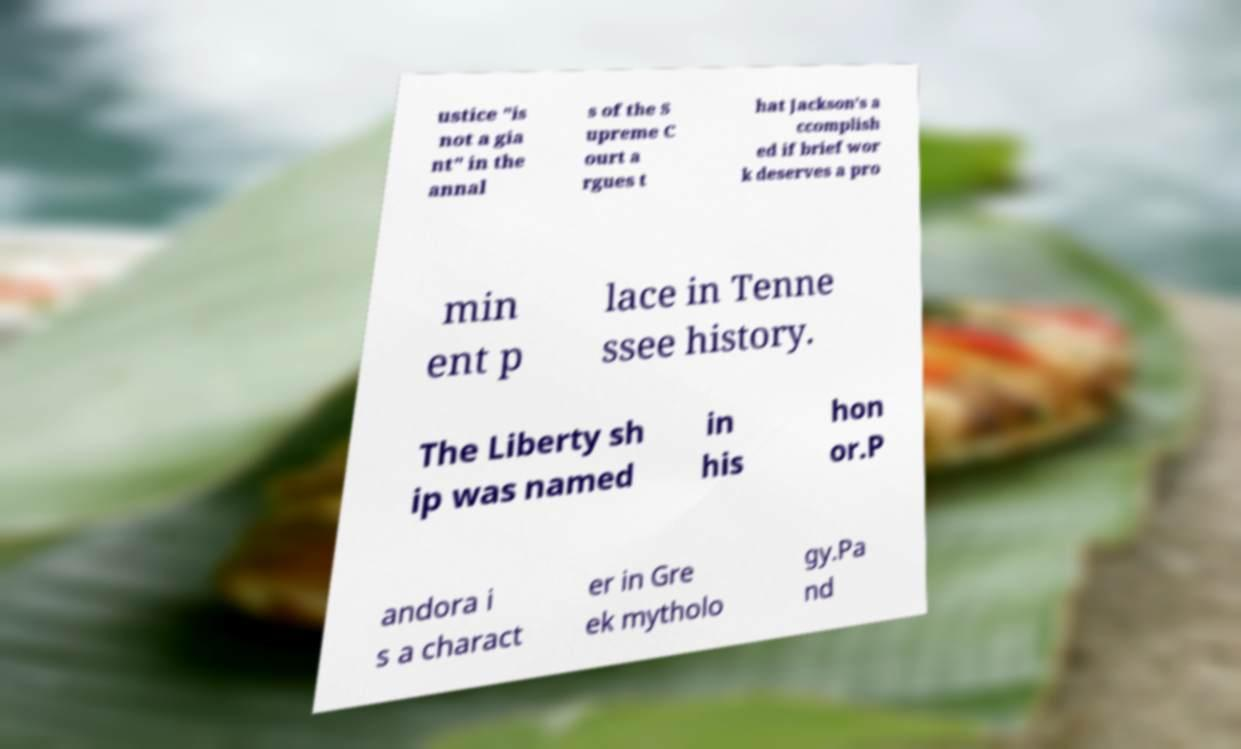Please identify and transcribe the text found in this image. ustice "is not a gia nt" in the annal s of the S upreme C ourt a rgues t hat Jackson's a ccomplish ed if brief wor k deserves a pro min ent p lace in Tenne ssee history. The Liberty sh ip was named in his hon or.P andora i s a charact er in Gre ek mytholo gy.Pa nd 